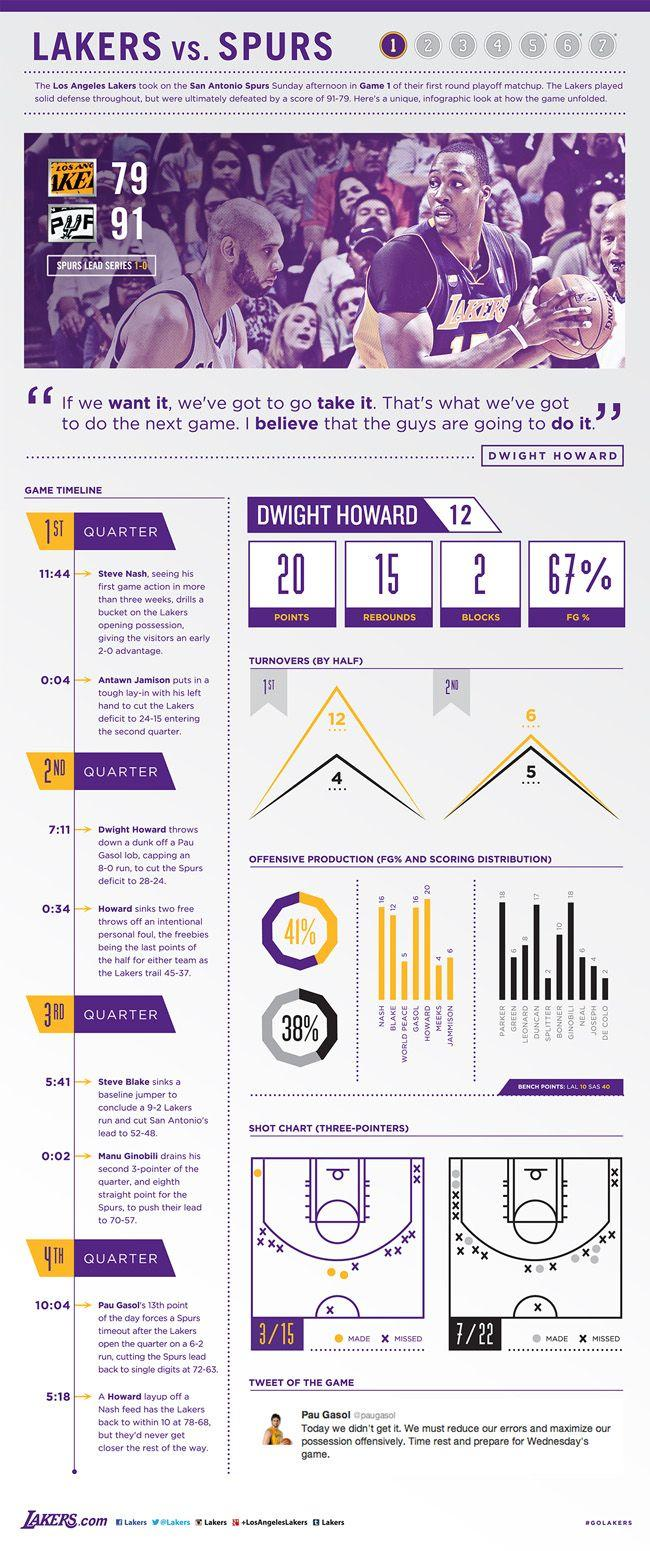Point out several critical features in this image. I have obtained 15 rebounds for Dwight Howard. Based on the shot chart from the 7/22 event, it is clear that there were 15 missed shots. According to the shot chart, there were 12 missed shots taken on March 15. 